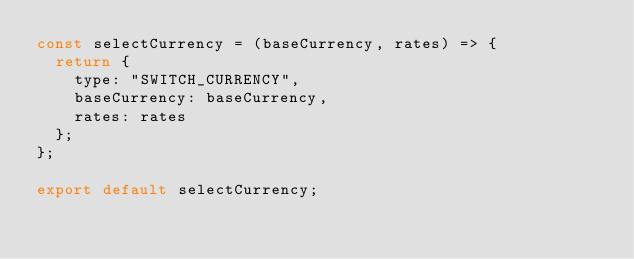Convert code to text. <code><loc_0><loc_0><loc_500><loc_500><_JavaScript_>const selectCurrency = (baseCurrency, rates) => {
  return {
    type: "SWITCH_CURRENCY",
    baseCurrency: baseCurrency,
    rates: rates
  };
};

export default selectCurrency;
</code> 